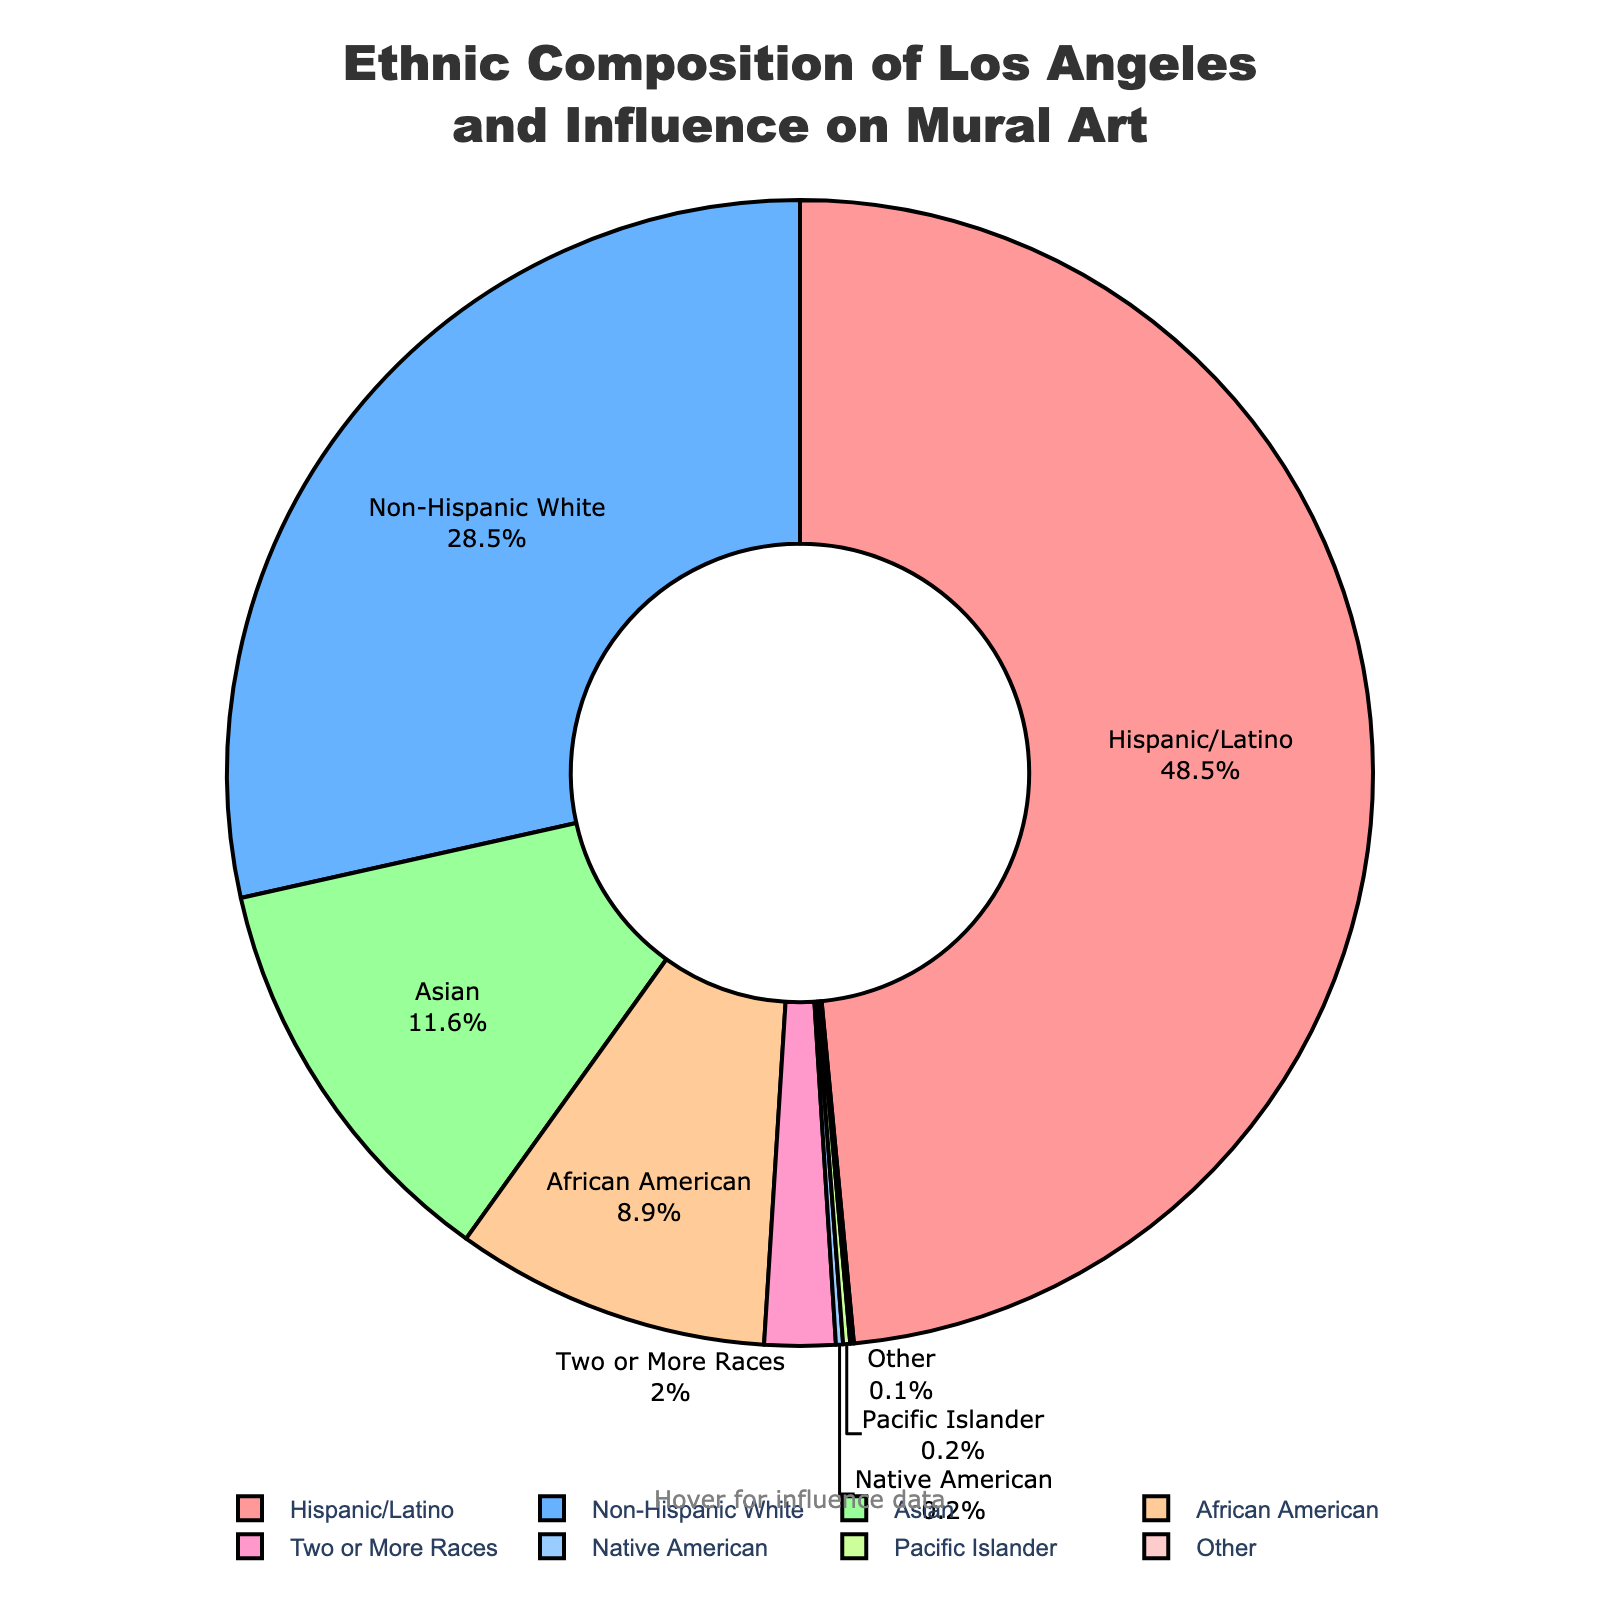Which ethnicity has the largest percentage of Los Angeles residents? The pie chart shows that Hispanic/Latino has the largest segment. By looking at the size of the slices, Hispanic/Latino is the most significant proportion.
Answer: Hispanic/Latino Which ethnicity contributes the least to mural art influence? The hover notes on the pie chart indicate that Pacific Islander and Other each have a 1% influence, which is the lowest among all groups.
Answer: Pacific Islander and Other What's the combined percentage of Non-Hispanic White and African American residents in Los Angeles? The percentage for Non-Hispanic White is 28.5%, and for African American, it is 8.9%. Adding them together is 28.5% + 8.9% = 37.4%.
Answer: 37.4% Comparing Hispanic/Latino and Asian residents, which group has a higher influence on mural art? The hover notes show that Hispanic/Latino has a 35% influence, while Asian residents have a 15% influence. 35% is greater than 15%.
Answer: Hispanic/Latino Which ethnic group, represented in blue on the chart, has a 20% influence on mural art? The pie chart uses colors to differentiate ethnicities. By looking at the legend, Non-Hispanic White is associated with the blue slice, and the hover note indicates a 20% influence.
Answer: Non-Hispanic White What is the average influence on mural art by the three largest ethnic groups (Hispanic/Latino, Non-Hispanic White, and Asian)? The influences are Hispanic/Latino (35%), Non-Hispanic White (20%), and Asian (15%). Sum them up: 35% + 20% + 15% = 70%. Divide by 3 to find the average: 70% / 3 ≈ 23.33%.
Answer: 23.33% How much more influence does African American have on mural art compared to Two or More Races? The influences are 18% for African American and 7% for Two or More Races. The difference is 18% - 7% = 11%.
Answer: 11% Which ethnicity, represented in green on the chart, accounts for 11.6% of the Los Angeles population? By referring to the pie chart's legend and matching the green color, Asian residents account for this percentage.
Answer: Asian What is the median percentage of Los Angeles residents when considering all ethnicities listed? Let's list out the percentages in ascending order: 0.1, 0.2, 0.2, 2.0, 8.9, 11.6, 28.5, 48.5. The median is the average of the 4th and 5th values: (2.0 + 8.9) / 2 = 10.45 / 2 = 5.225%.
Answer: 5.225% Is the percentage of Native American and Pacific Islander residents together greater than the percentage of Two or More Races? The percentages for Native American and Pacific Islander are both 0.2%, summing to 0.2% + 0.2% = 0.4%. The percentage for Two or More Races is 2.0%. 0.4% is less than 2.0%.
Answer: No 